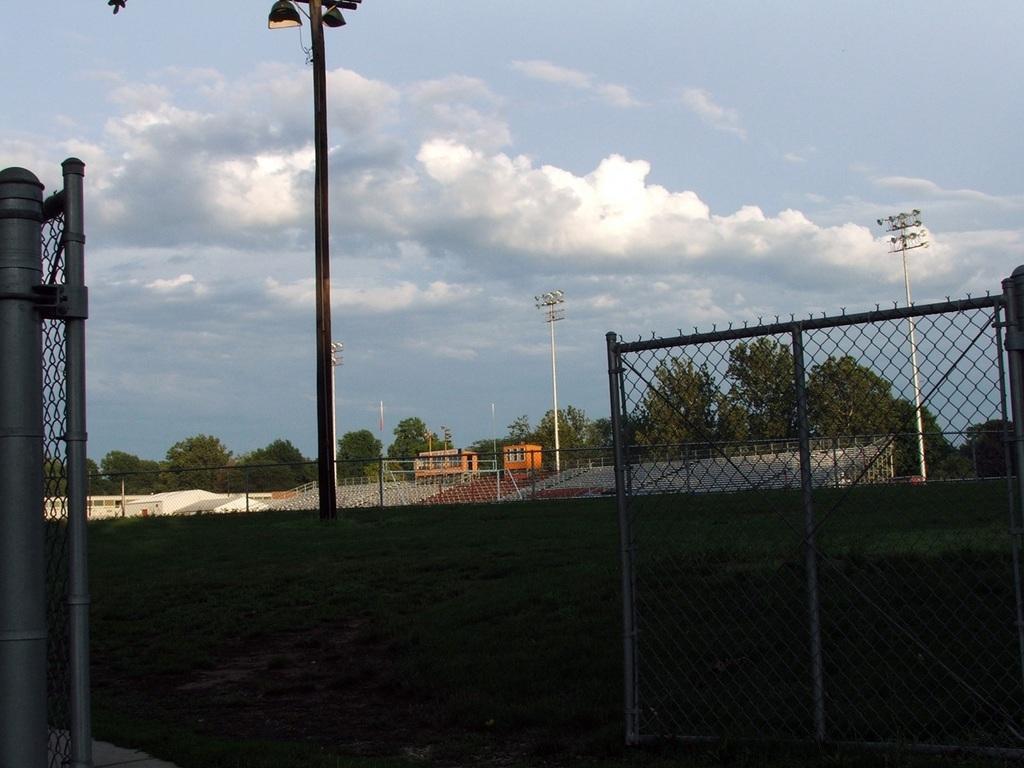How would you summarize this image in a sentence or two? This looks like a stadium. There is a pole in the middle. There is a fence in the middle. There are trees in the middle. There is sky at the top. 